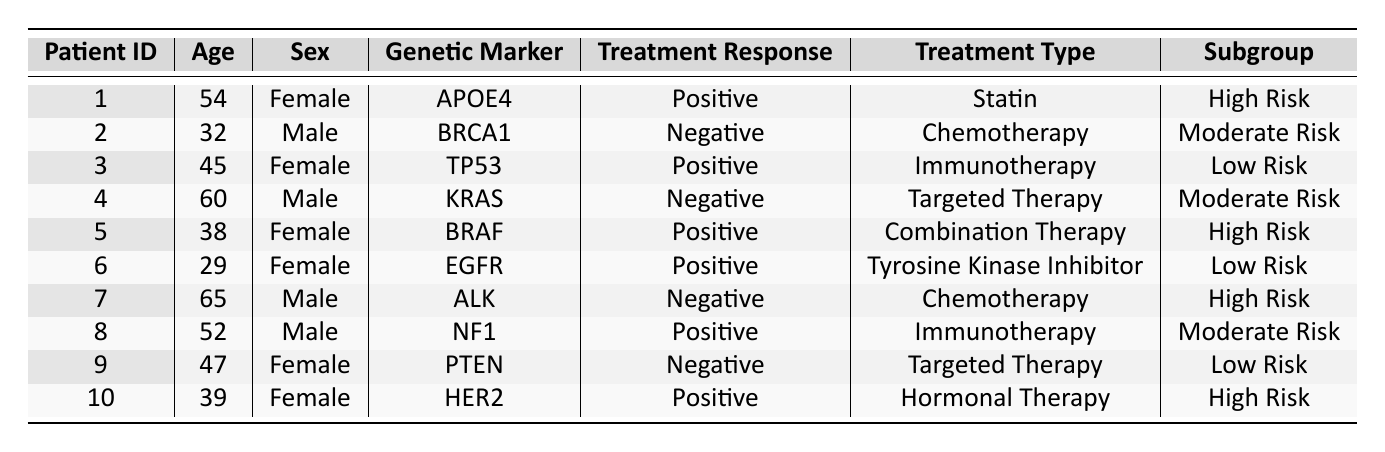What is the treatment response for patient ID 3? By looking at row 3 in the table, under the "Treatment Response" column, we see that the response is "Positive."
Answer: Positive How many female patients have a positive treatment response? The patients with a positive response are from rows 1, 3, 5, 6, 8, and 10. Among these, the female patients are in rows 1, 3, 5, and 10, which total 4 female patients.
Answer: 4 Is there a patient in the "High Risk" subgroup who received "Chemotherapy"? By examining the "Subgroup" and "Treatment Type" columns, we observe that the only patient in the "High Risk" subgroup who received "Chemotherapy" is patient ID 7, whose treatment response is "Negative." This means there is no patient with a "Positive" response.
Answer: No What percentage of patients in the "Low Risk" subgroup had a positive treatment response? There are 3 patients in the "Low Risk" subgroup (patient IDs 3, 6, and 9). Out of these, patients 3 and 6 had a positive response, resulting in 2 positive responses. To find the percentage: (2/3) * 100 = 66.67%.
Answer: 66.67% How does treatment response differ among male patients in the "Moderate Risk" subgroup? Checking the "Moderate Risk" subgroup for male patients, we find patients IDs 2 (Negative) and 4 (Negative), and patient ID 8 (Positive). Both 2 and 4 had a Negative response, while 8 had a Positive response. The difference indicates that none of the male patients in this subgroup responded positively to the treatments provided.
Answer: None had a positive response What is the average age of patients who responded positively to treatment? The ages of patients with a positive response (IDs 1, 3, 5, 6, 8, and 10) are 54, 45, 38, 29, 52, and 39. To find the average: (54 + 45 + 38 + 29 + 52 + 39) / 6 = 43.8333, rounding to 44 is acceptable.
Answer: 44 Are there any patients with the genetic marker "BRAF" in the "High Risk" subgroup? Patient ID 5 is noted for the genetic marker "BRAF," and this patient is in the "High Risk" subgroup. Thus, the statement is true.
Answer: Yes Which genetic markers are associated with negative treatment responses? The negative responses correspond to genetic markers "BRCA1," "KRAS," "ALK," and "PTEN," found in patients IDs 2, 4, 7, and 9 respectively. This means the associated markers for negative responses are noted above, confirming their correlation.
Answer: BRCA1, KRAS, ALK, PTEN Which treatment types yielded positive responses from patients aged over 50? Checking the ages over 50 with positive responses, we find patient 1 (Statin), patient 5 (Combination Therapy), and patient 8 (Immunotherapy). Hence, the treatment types yielding positive responses for these patients are listed as such: Statin, Combination Therapy, and Immunotherapy.
Answer: Statin, Combination Therapy, Immunotherapy 